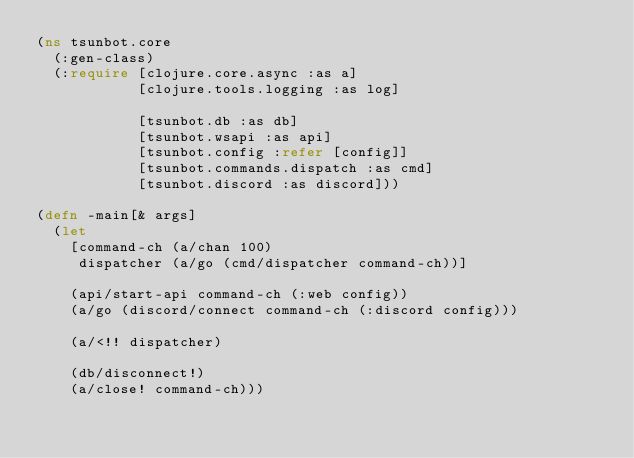<code> <loc_0><loc_0><loc_500><loc_500><_Clojure_>(ns tsunbot.core
  (:gen-class)
  (:require [clojure.core.async :as a]
            [clojure.tools.logging :as log]

            [tsunbot.db :as db]
            [tsunbot.wsapi :as api]
            [tsunbot.config :refer [config]]
            [tsunbot.commands.dispatch :as cmd]
            [tsunbot.discord :as discord]))

(defn -main[& args]
  (let
    [command-ch (a/chan 100)
     dispatcher (a/go (cmd/dispatcher command-ch))]

    (api/start-api command-ch (:web config))
    (a/go (discord/connect command-ch (:discord config)))

    (a/<!! dispatcher)

    (db/disconnect!)
    (a/close! command-ch)))
</code> 